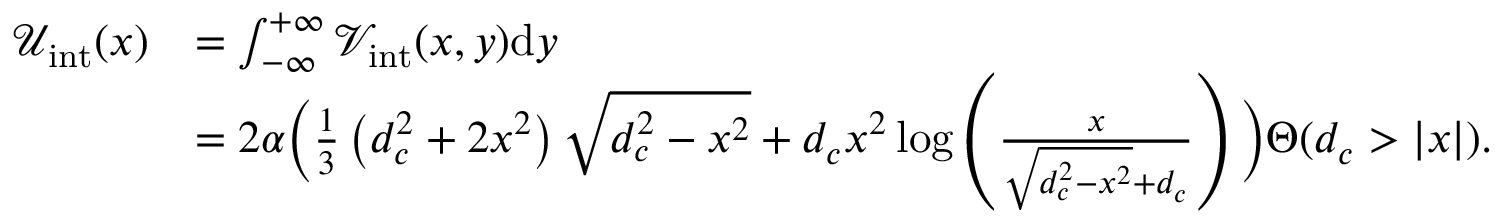<formula> <loc_0><loc_0><loc_500><loc_500>\begin{array} { r l } { \mathcal { U } _ { i n t } ( x ) } & { = \int _ { - \infty } ^ { + \infty } \mathcal { V } _ { i n t } ( x , y ) d y } \\ & { = 2 \alpha \left ( \frac { 1 } { 3 } \left ( d _ { c } ^ { 2 } + 2 x ^ { 2 } \right ) \sqrt { d _ { c } ^ { 2 } - x ^ { 2 } } + d _ { c } x ^ { 2 } \log \left ( \frac { x } { \sqrt { d _ { c } ^ { 2 } - x ^ { 2 } } + d _ { c } } \right ) \right ) \Theta ( d _ { c } > | x | ) . } \end{array}</formula> 